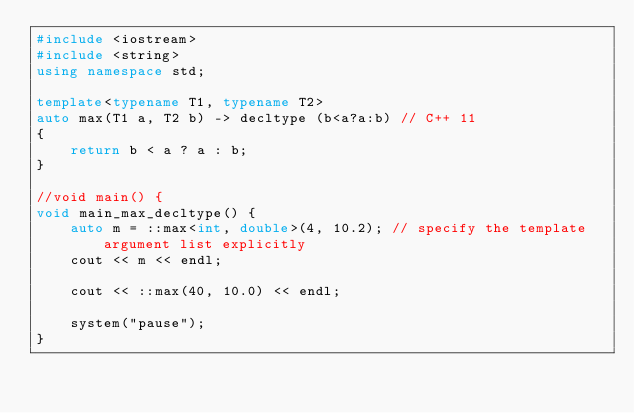Convert code to text. <code><loc_0><loc_0><loc_500><loc_500><_C++_>#include <iostream>
#include <string>
using namespace std;

template<typename T1, typename T2>
auto max(T1 a, T2 b) -> decltype (b<a?a:b) // C++ 11
{
	return b < a ? a : b;
}

//void main() {
void main_max_decltype() {
	auto m = ::max<int, double>(4, 10.2); // specify the template argument list explicitly
	cout << m << endl;

	cout << ::max(40, 10.0) << endl;

	system("pause");
}
</code> 